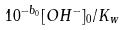Convert formula to latex. <formula><loc_0><loc_0><loc_500><loc_500>1 0 ^ { - b _ { 0 } } [ O H ^ { - } ] _ { 0 } / K _ { w }</formula> 